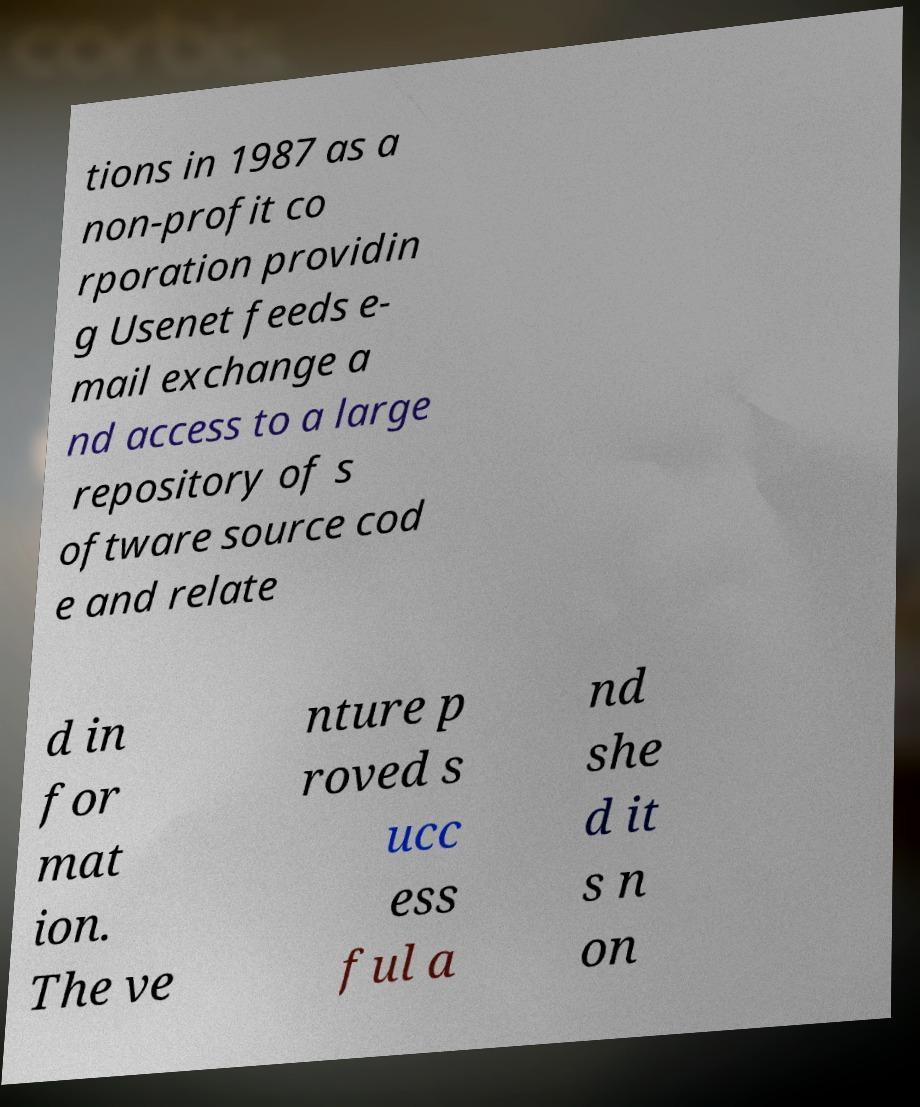Could you assist in decoding the text presented in this image and type it out clearly? tions in 1987 as a non-profit co rporation providin g Usenet feeds e- mail exchange a nd access to a large repository of s oftware source cod e and relate d in for mat ion. The ve nture p roved s ucc ess ful a nd she d it s n on 